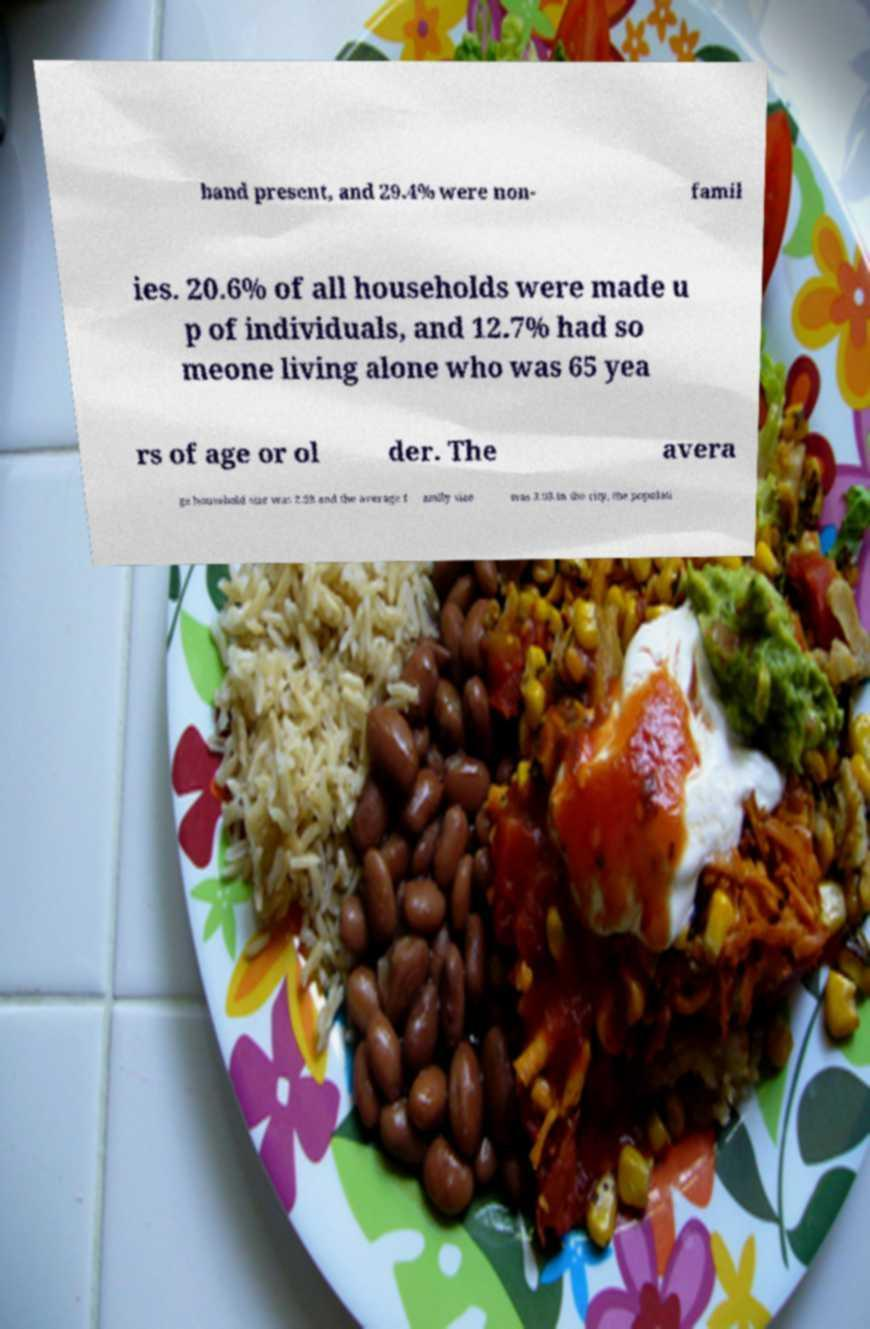Could you extract and type out the text from this image? band present, and 29.4% were non- famil ies. 20.6% of all households were made u p of individuals, and 12.7% had so meone living alone who was 65 yea rs of age or ol der. The avera ge household size was 2.58 and the average f amily size was 3.03.In the city, the populati 